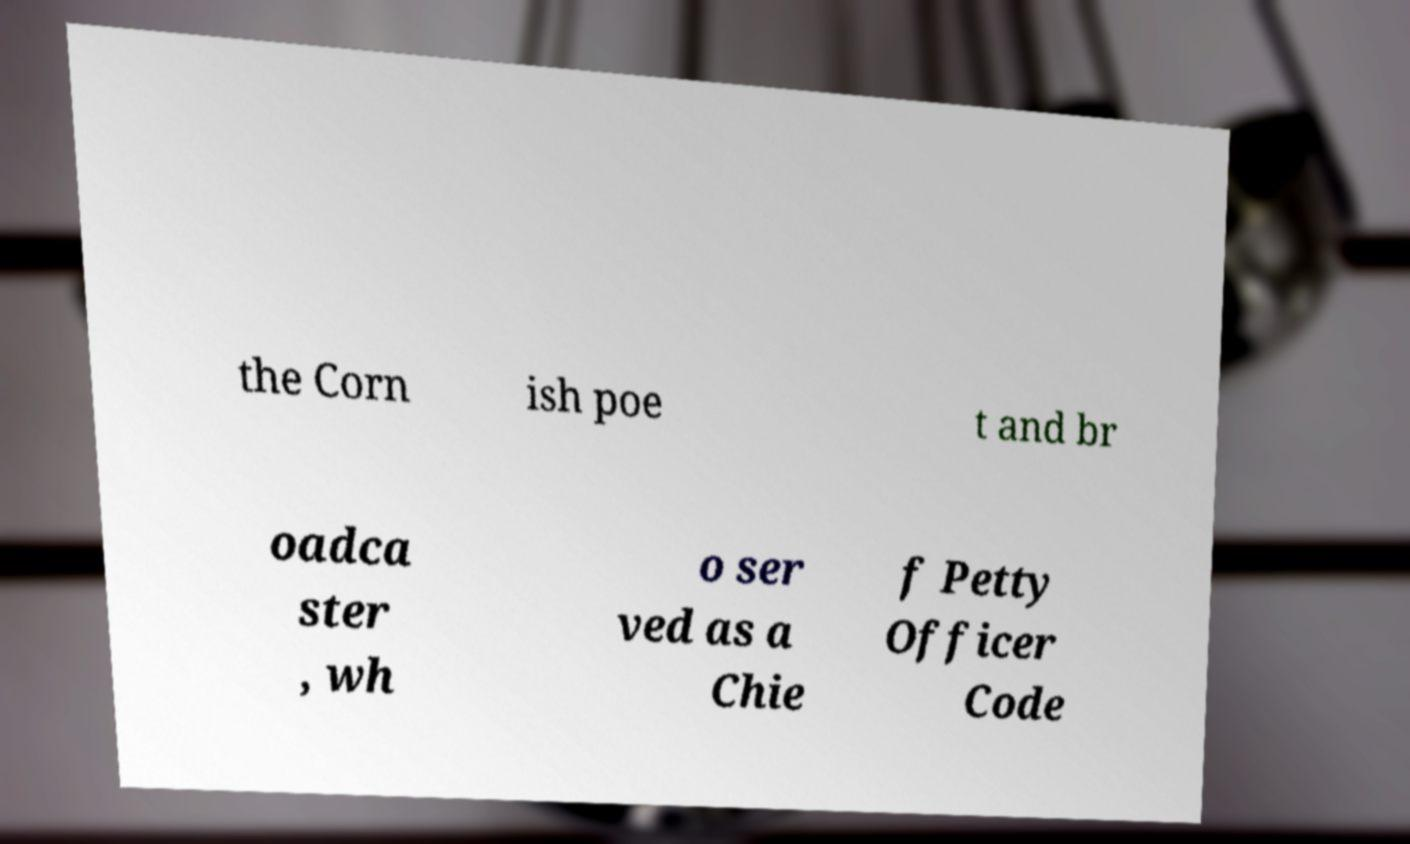Could you extract and type out the text from this image? the Corn ish poe t and br oadca ster , wh o ser ved as a Chie f Petty Officer Code 